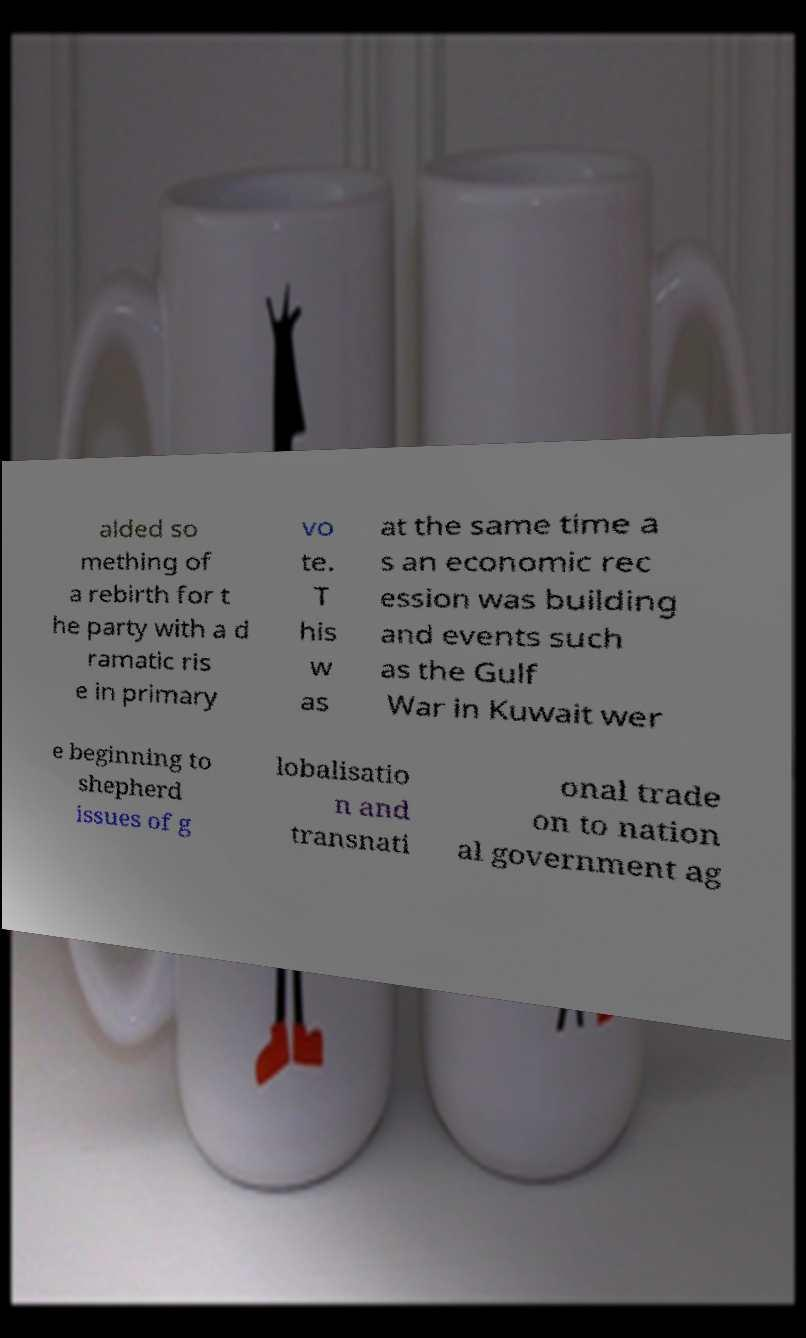Can you accurately transcribe the text from the provided image for me? alded so mething of a rebirth for t he party with a d ramatic ris e in primary vo te. T his w as at the same time a s an economic rec ession was building and events such as the Gulf War in Kuwait wer e beginning to shepherd issues of g lobalisatio n and transnati onal trade on to nation al government ag 